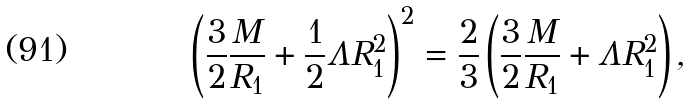Convert formula to latex. <formula><loc_0><loc_0><loc_500><loc_500>\left ( \frac { 3 } { 2 } \frac { M } { R _ { 1 } } + \frac { 1 } { 2 } \Lambda R _ { 1 } ^ { 2 } \right ) ^ { 2 } = \frac { 2 } { 3 } \left ( \frac { 3 } { 2 } \frac { M } { R _ { 1 } } + \Lambda R _ { 1 } ^ { 2 } \right ) ,</formula> 